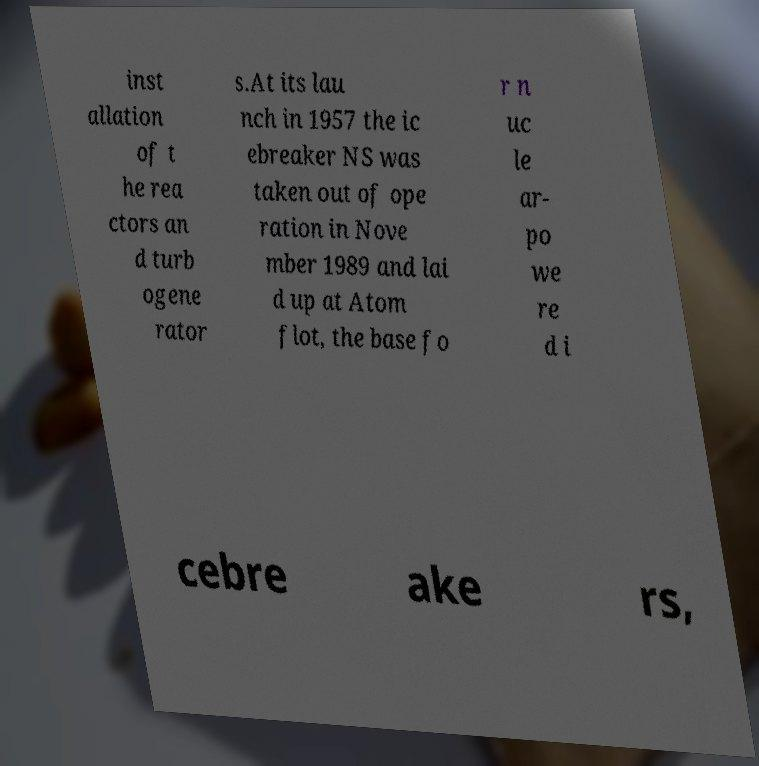What messages or text are displayed in this image? I need them in a readable, typed format. inst allation of t he rea ctors an d turb ogene rator s.At its lau nch in 1957 the ic ebreaker NS was taken out of ope ration in Nove mber 1989 and lai d up at Atom flot, the base fo r n uc le ar- po we re d i cebre ake rs, 